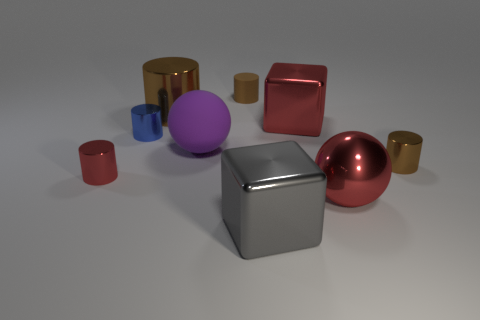What is the large cube that is in front of the blue object made of?
Give a very brief answer. Metal. Is the big brown object the same shape as the gray thing?
Make the answer very short. No. There is a small shiny cylinder that is on the right side of the small brown thing that is behind the tiny metal cylinder on the right side of the gray object; what color is it?
Offer a very short reply. Brown. What number of large metal things have the same shape as the brown rubber object?
Give a very brief answer. 1. How big is the brown metal cylinder in front of the large brown shiny object to the left of the red sphere?
Keep it short and to the point. Small. Is the red cylinder the same size as the blue metallic object?
Your answer should be compact. Yes. There is a small brown cylinder behind the blue cylinder behind the gray thing; is there a blue metallic cylinder left of it?
Ensure brevity in your answer.  Yes. What is the size of the metal sphere?
Give a very brief answer. Large. What number of cylinders are the same size as the blue metal object?
Ensure brevity in your answer.  3. There is a tiny red thing that is the same shape as the big brown thing; what is it made of?
Give a very brief answer. Metal. 